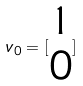Convert formula to latex. <formula><loc_0><loc_0><loc_500><loc_500>v _ { 0 } = [ \begin{matrix} 1 \\ 0 \end{matrix} ]</formula> 